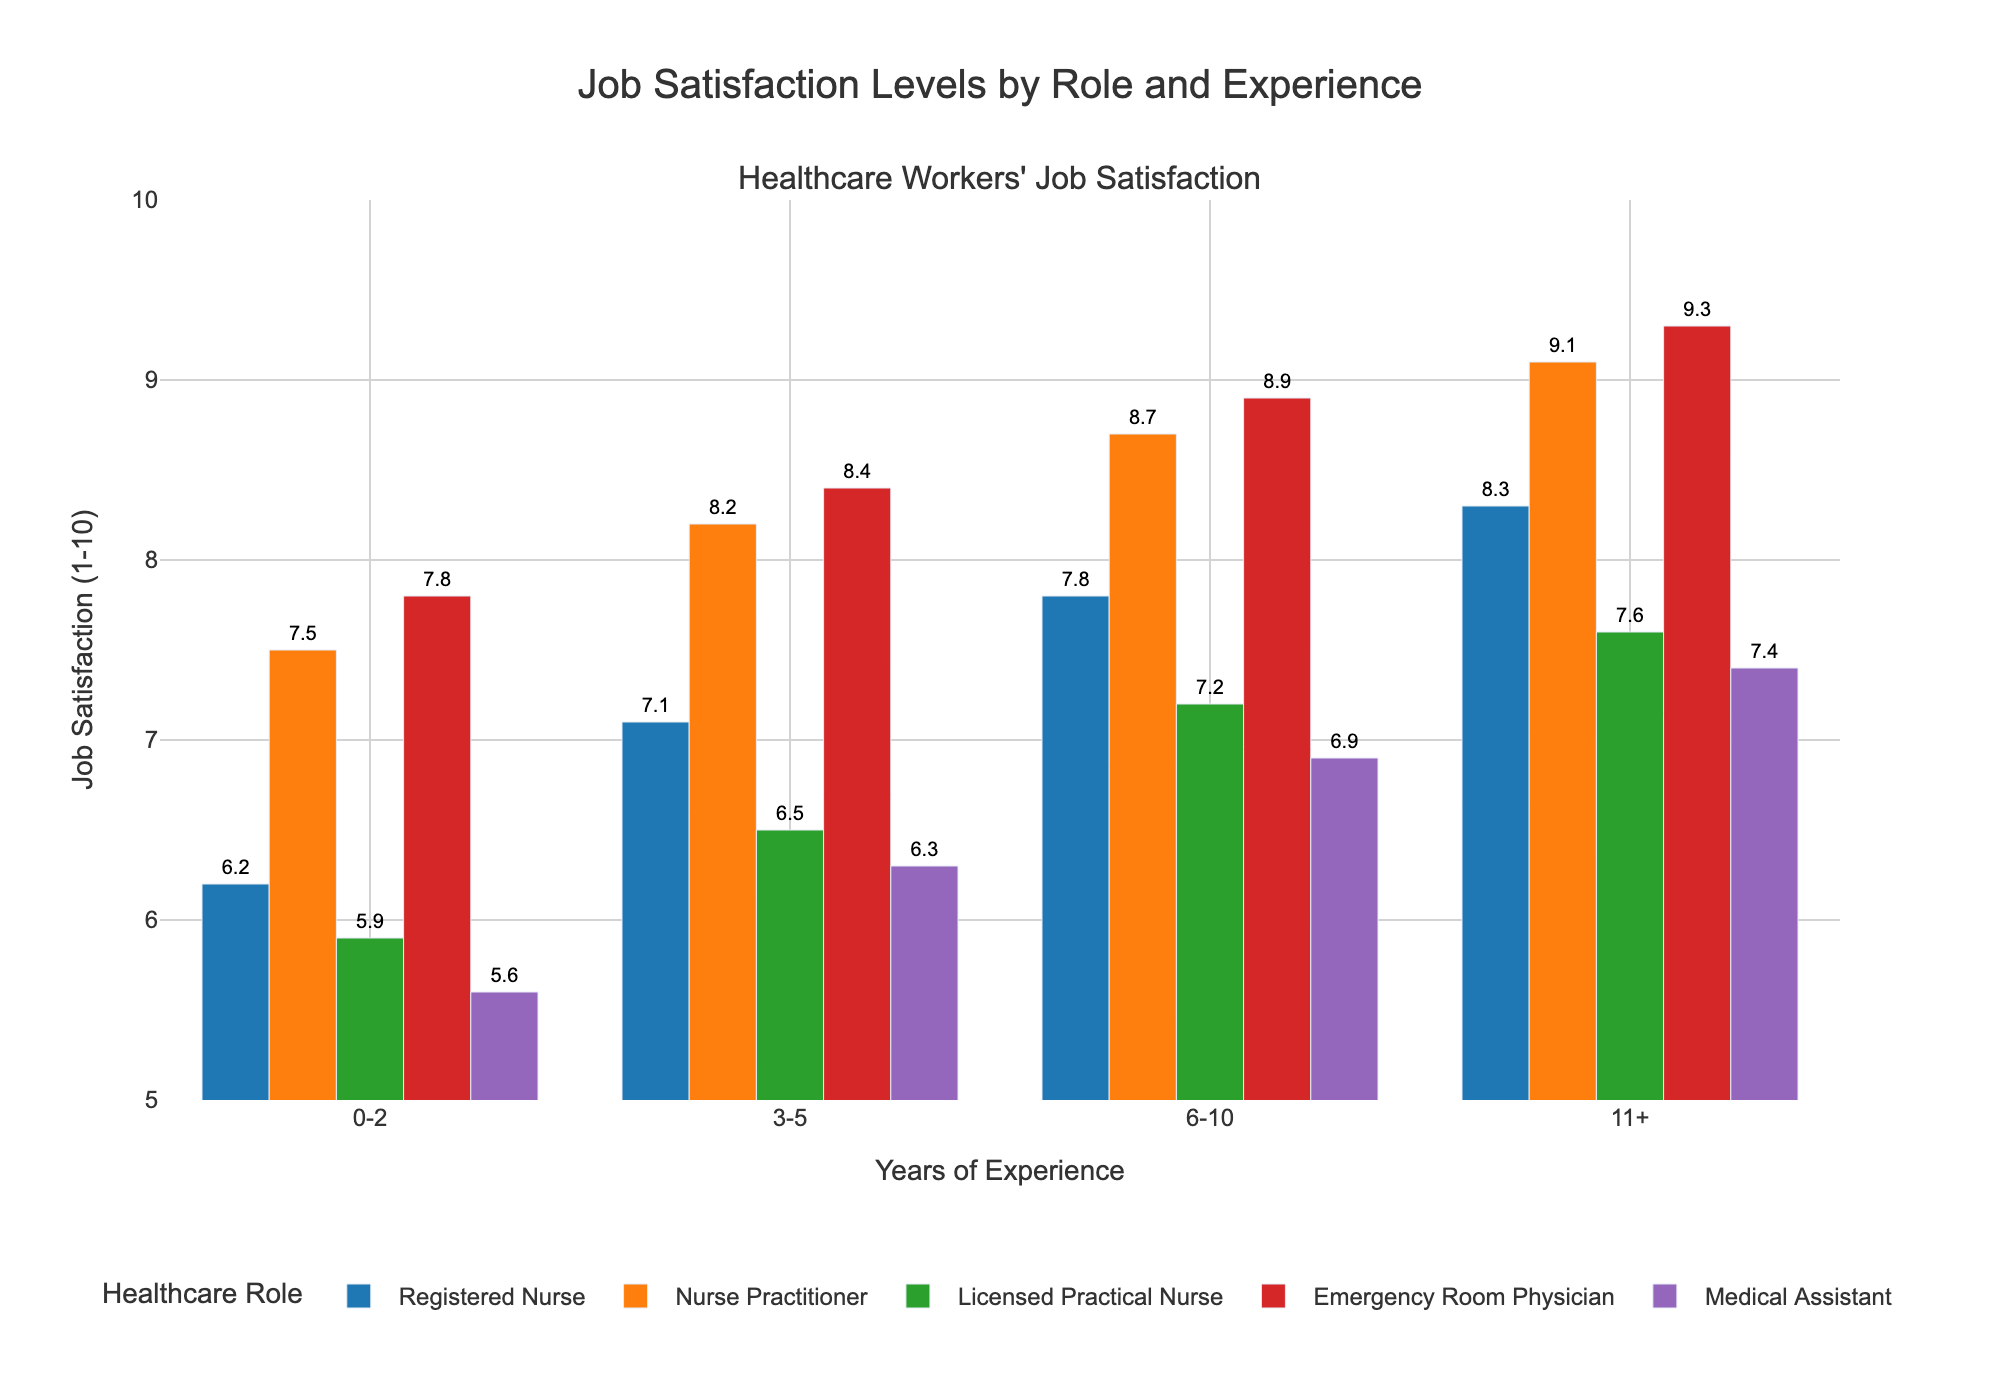Which role has the highest job satisfaction level for 0-2 years of experience? Look at the bars representing the 0-2 years experience category and compare their heights. The Emergency Room Physician's bar for 0-2 years is the tallest.
Answer: Emergency Room Physician How does the job satisfaction of Registered Nurses with 3-5 years of experience compare to Nurse Practitioners with the same years of experience? Compare the heights of the bars for Registered Nurses and Nurse Practitioners in the 3-5 years experience category. The bar for Nurse Practitioners is taller.
Answer: Nurse Practitioners What is the average job satisfaction level of Medical Assistants across all years of experience? Calculate the mean of job satisfaction values for each experience category: (5.6 + 6.3 + 6.9 + 7.4) / 4 = 6.55
Answer: 6.55 Which group has the lowest job satisfaction level for 0-2 years of experience? Examine the bars for the 0-2 years experience category and find the shortest one. The bar representing Medical Assistants is the shortest.
Answer: Medical Assistant How much higher is the job satisfaction of Nurse Practitioners with 6-10 years of experience compared to Licensed Practical Nurses with the same years of experience? Subtract the job satisfaction score of Licensed Practical Nurses from that of Nurse Practitioners: 8.7 - 7.2 = 1.5
Answer: 1.5 What visual pattern do you notice for job satisfaction levels across different years of experience within each role? Observe the bars within each role over different experience categories. For all roles, the bar height generally increases as years of experience increase, indicating increasing job satisfaction.
Answer: Increasing with experience Identify the role with the greatest improvement in job satisfaction from 0-2 years to 11+ years. Subtract the 0-2 years job satisfaction score from the 11+ years score for each role. The role with the highest difference is Emergency Room Physician: 9.3 - 7.8 = 1.5
Answer: Emergency Room Physician Which experience category has the highest overall job satisfaction level across all roles? Look for the tallest bar among all experience categories and roles. The 11+ years experience category for Emergency Room Physicians has the highest job satisfaction level.
Answer: 11+ Is the job satisfaction level of Licensed Practical Nurses with 11+ years of experience higher or lower than Registered Nurses with 6-10 years of experience? Compare the bars of Licensed Practical Nurses with 11+ years experience and Registered Nurses with 6-10 years experience. The Registered Nurses have higher job satisfaction.
Answer: Lower Does the job satisfaction level of Nurse Practitioners with 3-5 years of experience exceed that of Medical Assistants with 11+ years of experience? Compare the heights of the bars for Nurse Practitioners with 3-5 years and Medical Assistants with 11+ years. The Nurse Practitioners' bar is taller.
Answer: Yes 